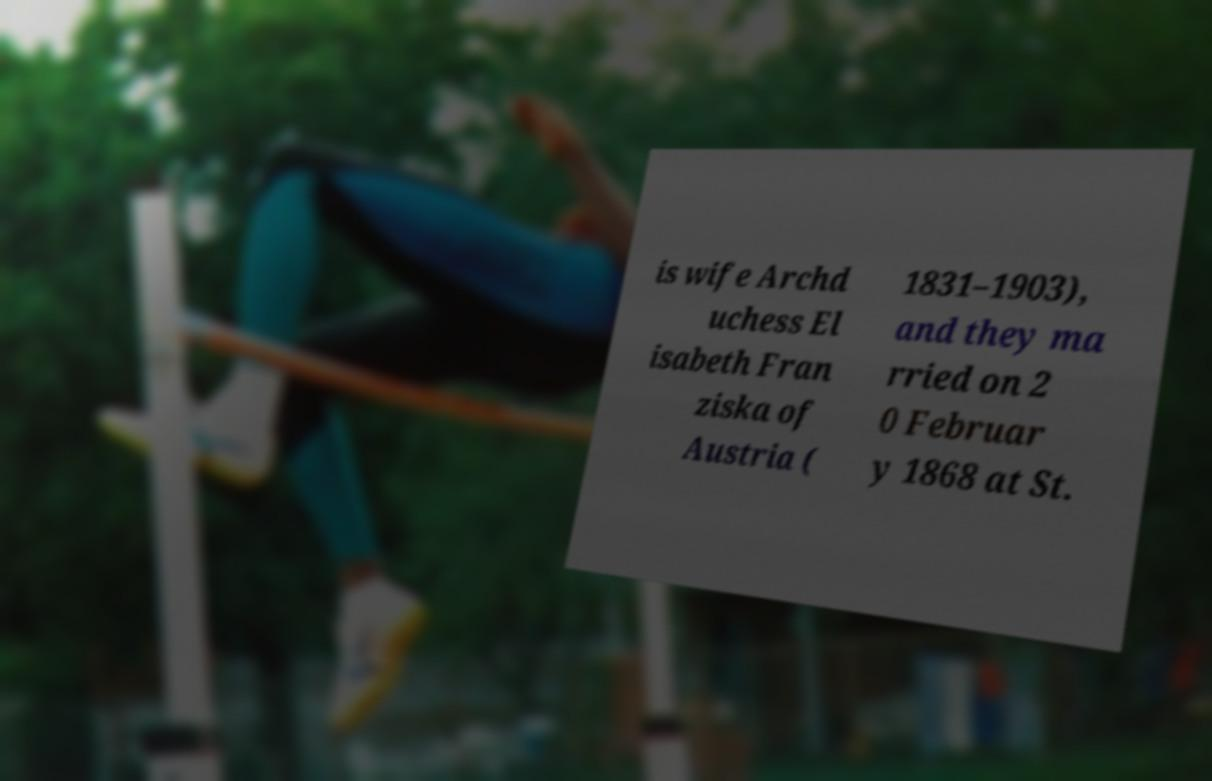Can you read and provide the text displayed in the image?This photo seems to have some interesting text. Can you extract and type it out for me? is wife Archd uchess El isabeth Fran ziska of Austria ( 1831–1903), and they ma rried on 2 0 Februar y 1868 at St. 